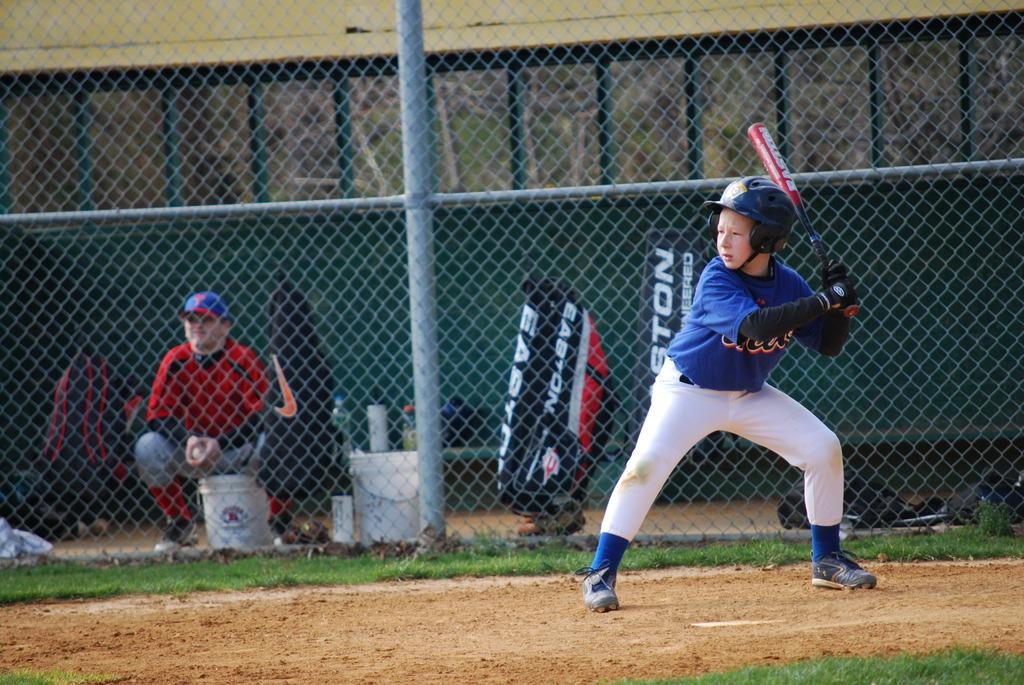<image>
Create a compact narrative representing the image presented. a boy holding a bat with the word Easton on a bag 